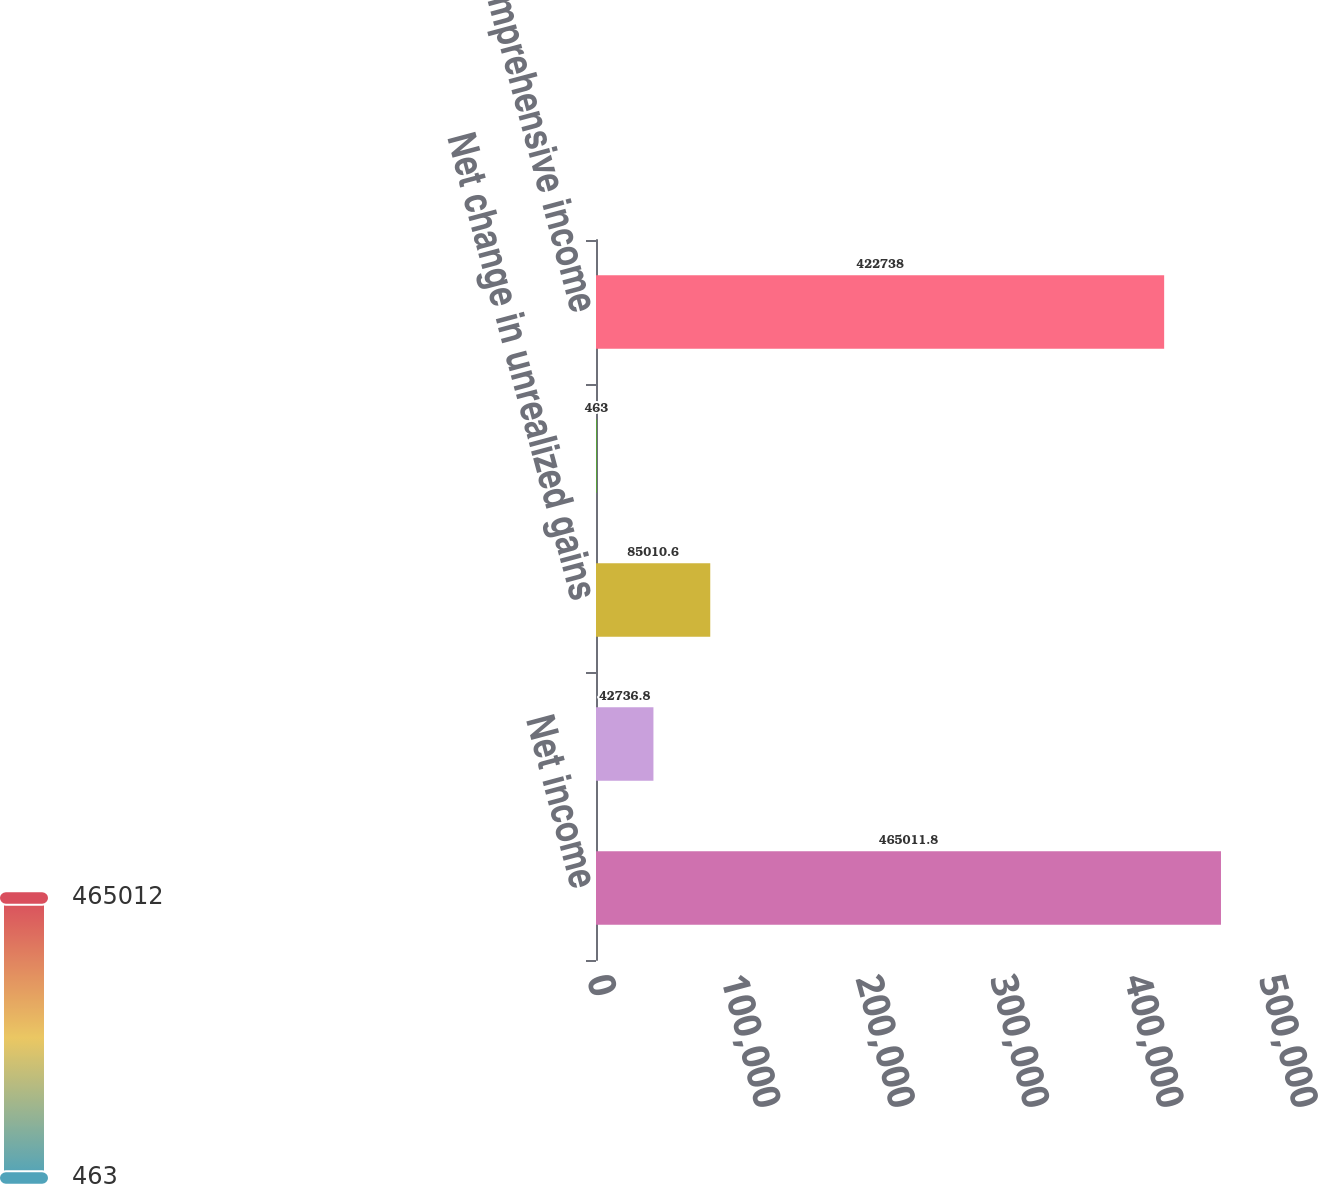<chart> <loc_0><loc_0><loc_500><loc_500><bar_chart><fcel>Net income<fcel>Foreign currency translation<fcel>Net change in unrealized gains<fcel>Other comprehensive loss<fcel>Comprehensive income<nl><fcel>465012<fcel>42736.8<fcel>85010.6<fcel>463<fcel>422738<nl></chart> 